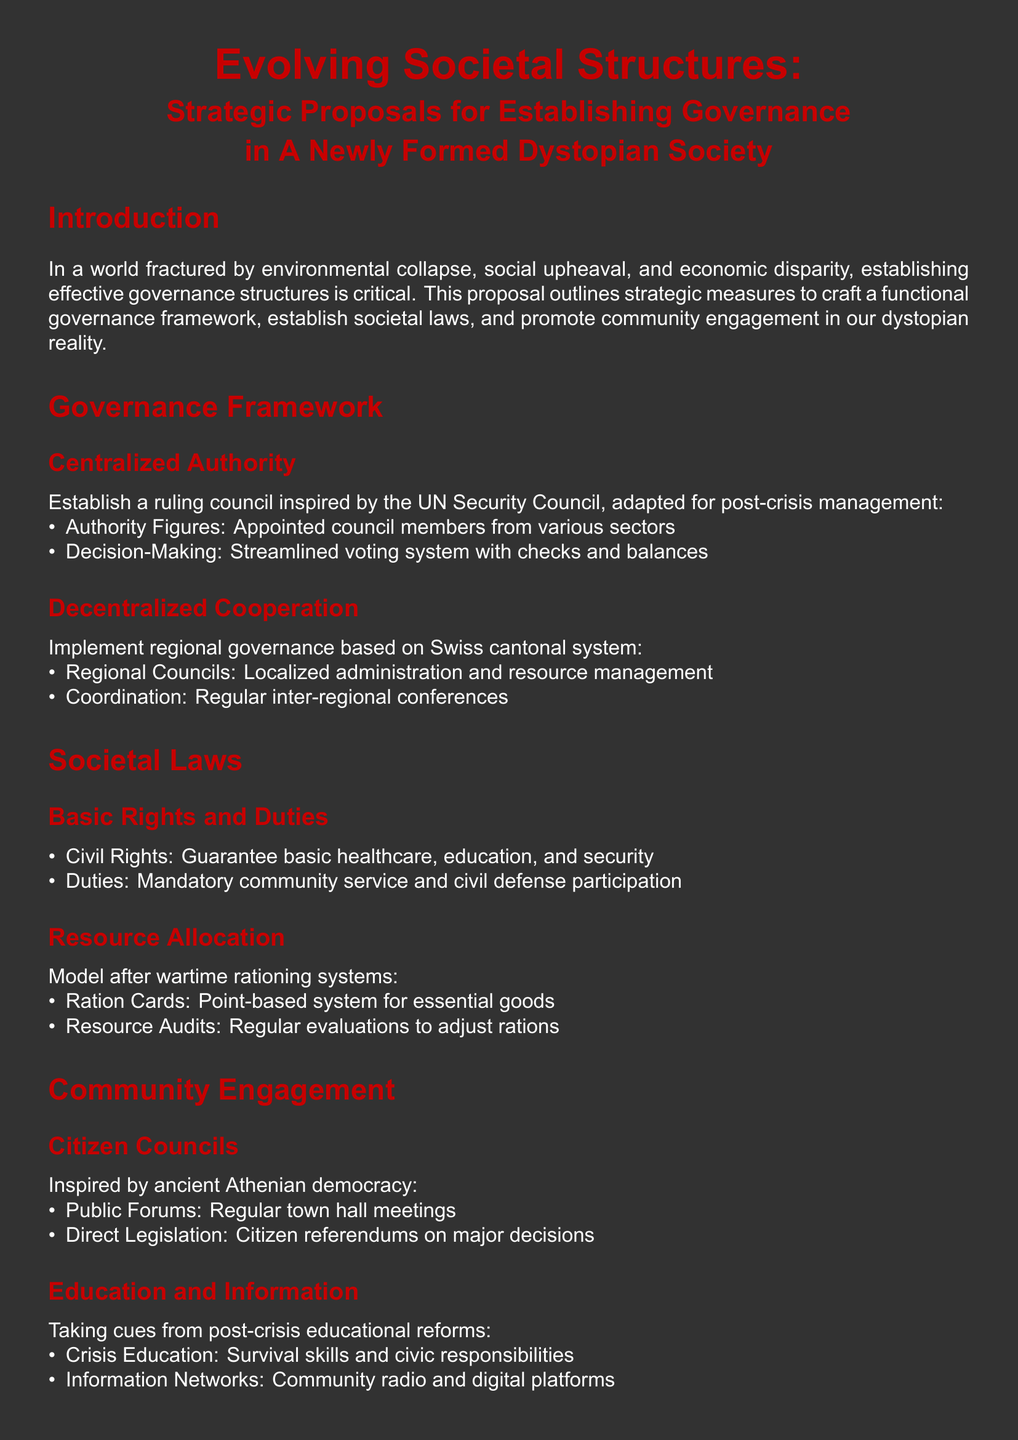what is the title of the proposal? The title is presented at the beginning of the document.
Answer: Evolving Societal Structures: Strategic Proposals for Establishing Governance in A Newly Formed Dystopian Society how many sections are in the proposal? The proposal contains several major sections which can be counted.
Answer: 5 what type of authority is proposed for governance? The document specifies the type of governance structure proposed.
Answer: Centralized Authority what is the primary focus of community engagement? The proposal outlines the method of engaging the community in governance decisions.
Answer: Citizen Councils what is one basic duty outlined in the societal laws? The proposal lists duties that citizens are expected to undertake in the new society.
Answer: Mandatory community service which historical system inspired the Citizen Councils? The proposal mentions a historical system that serves as a model for engaging citizens.
Answer: Ancient Athenian democracy how are essential goods allocated according to the proposal? The document describes a method for resource allocation during times of need.
Answer: Ration Cards what type of educational content is prioritized? The proposal highlights a specific area of education that is deemed essential.
Answer: Crisis Education what will be conducted regularly to adjust rations? The document specifies an activity that keeps track of resource levels.
Answer: Resource Audits 